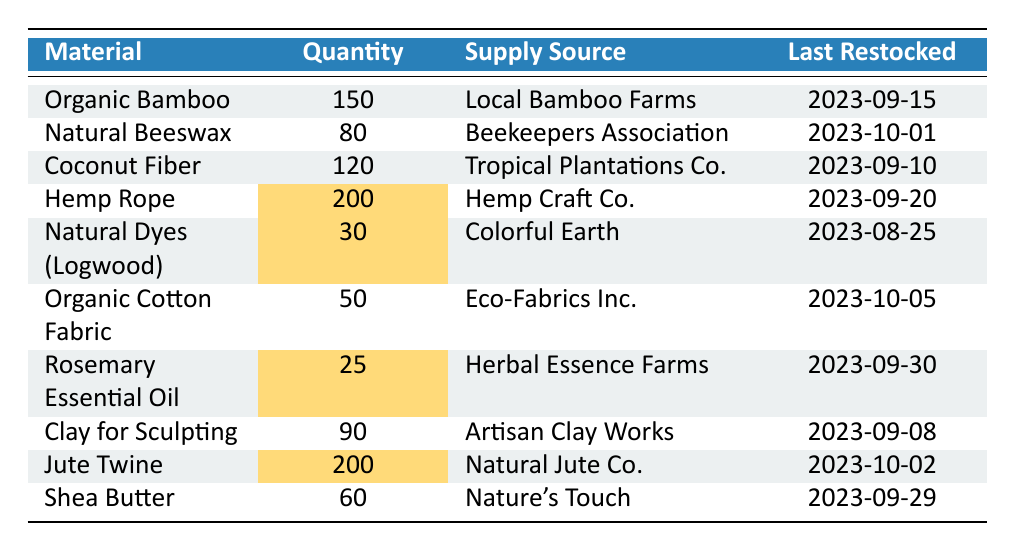What is the available quantity of Organic Bamboo? The table lists the available quantity of Organic Bamboo directly under the "Quantity" column, which shows 150.
Answer: 150 Who supplies the Natural Beeswax? The "Supply Source" column in the table indicates that the Natural Beeswax is supplied by the Beekeepers Association.
Answer: Beekeepers Association How many materials available have a quantity greater than 100? By checking each row in the "Quantity" column, we find that Organic Bamboo, Coconut Fiber, Hemp Rope, and Jute Twine have quantities greater than 100, totaling four materials.
Answer: 4 Is the last restock date of Rosemary Essential Oil after Natural Dyes (Logwood)? The last restock date for Rosemary Essential Oil is 2023-09-30 and for Natural Dyes (Logwood) is 2023-08-25. Since 2023-09-30 is later, the statement is true.
Answer: Yes What is the total quantity of materials that were last restocked in September 2023? From the table, count the quantities of the materials last restocked in September: Organic Bamboo (150), Coconut Fiber (120), Hemp Rope (200), Clay for Sculpting (90), Shea Butter (60), and Jute Twine (200). Summing these gives 150 + 120 + 200 + 90 + 60 + 200 = 820.
Answer: 820 What is the average available quantity of all organic materials listed? First, sum the available quantities: 150 + 80 + 120 + 200 + 30 + 50 + 25 + 90 + 200 + 60 = 1055. With 10 materials included, the average is 1055 / 10 = 105.5.
Answer: 105.5 Are there any materials available with less than 30 units? The table shows Rosemary Essential Oil with 25 units and Natural Dyes (Logwood) with 30 units. Since 25 is less than 30, the statement is true.
Answer: Yes What is the quantity difference between the material with the highest availability and the one with the lowest? The material with the highest quantity is Hemp Rope with 200, and the lowest is Rosemary Essential Oil with 25. The difference is 200 - 25 = 175.
Answer: 175 